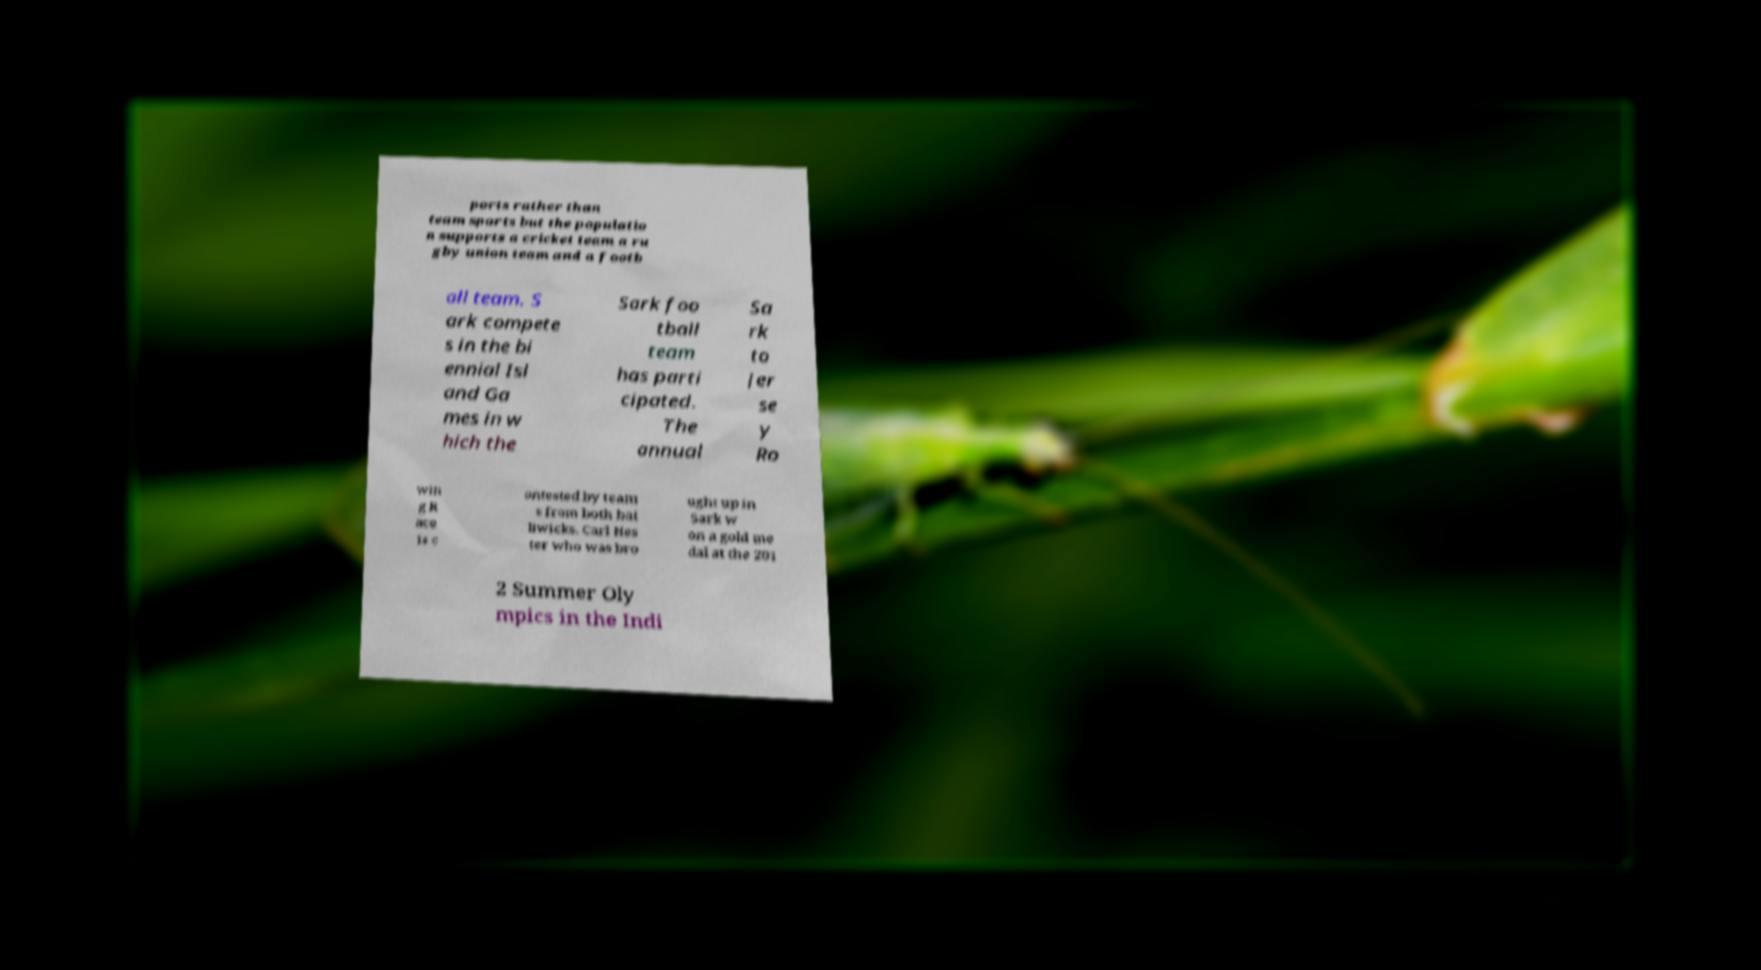Could you extract and type out the text from this image? ports rather than team sports but the populatio n supports a cricket team a ru gby union team and a footb all team. S ark compete s in the bi ennial Isl and Ga mes in w hich the Sark foo tball team has parti cipated. The annual Sa rk to Jer se y Ro win g R ace is c ontested by team s from both bai liwicks. Carl Hes ter who was bro ught up in Sark w on a gold me dal at the 201 2 Summer Oly mpics in the Indi 